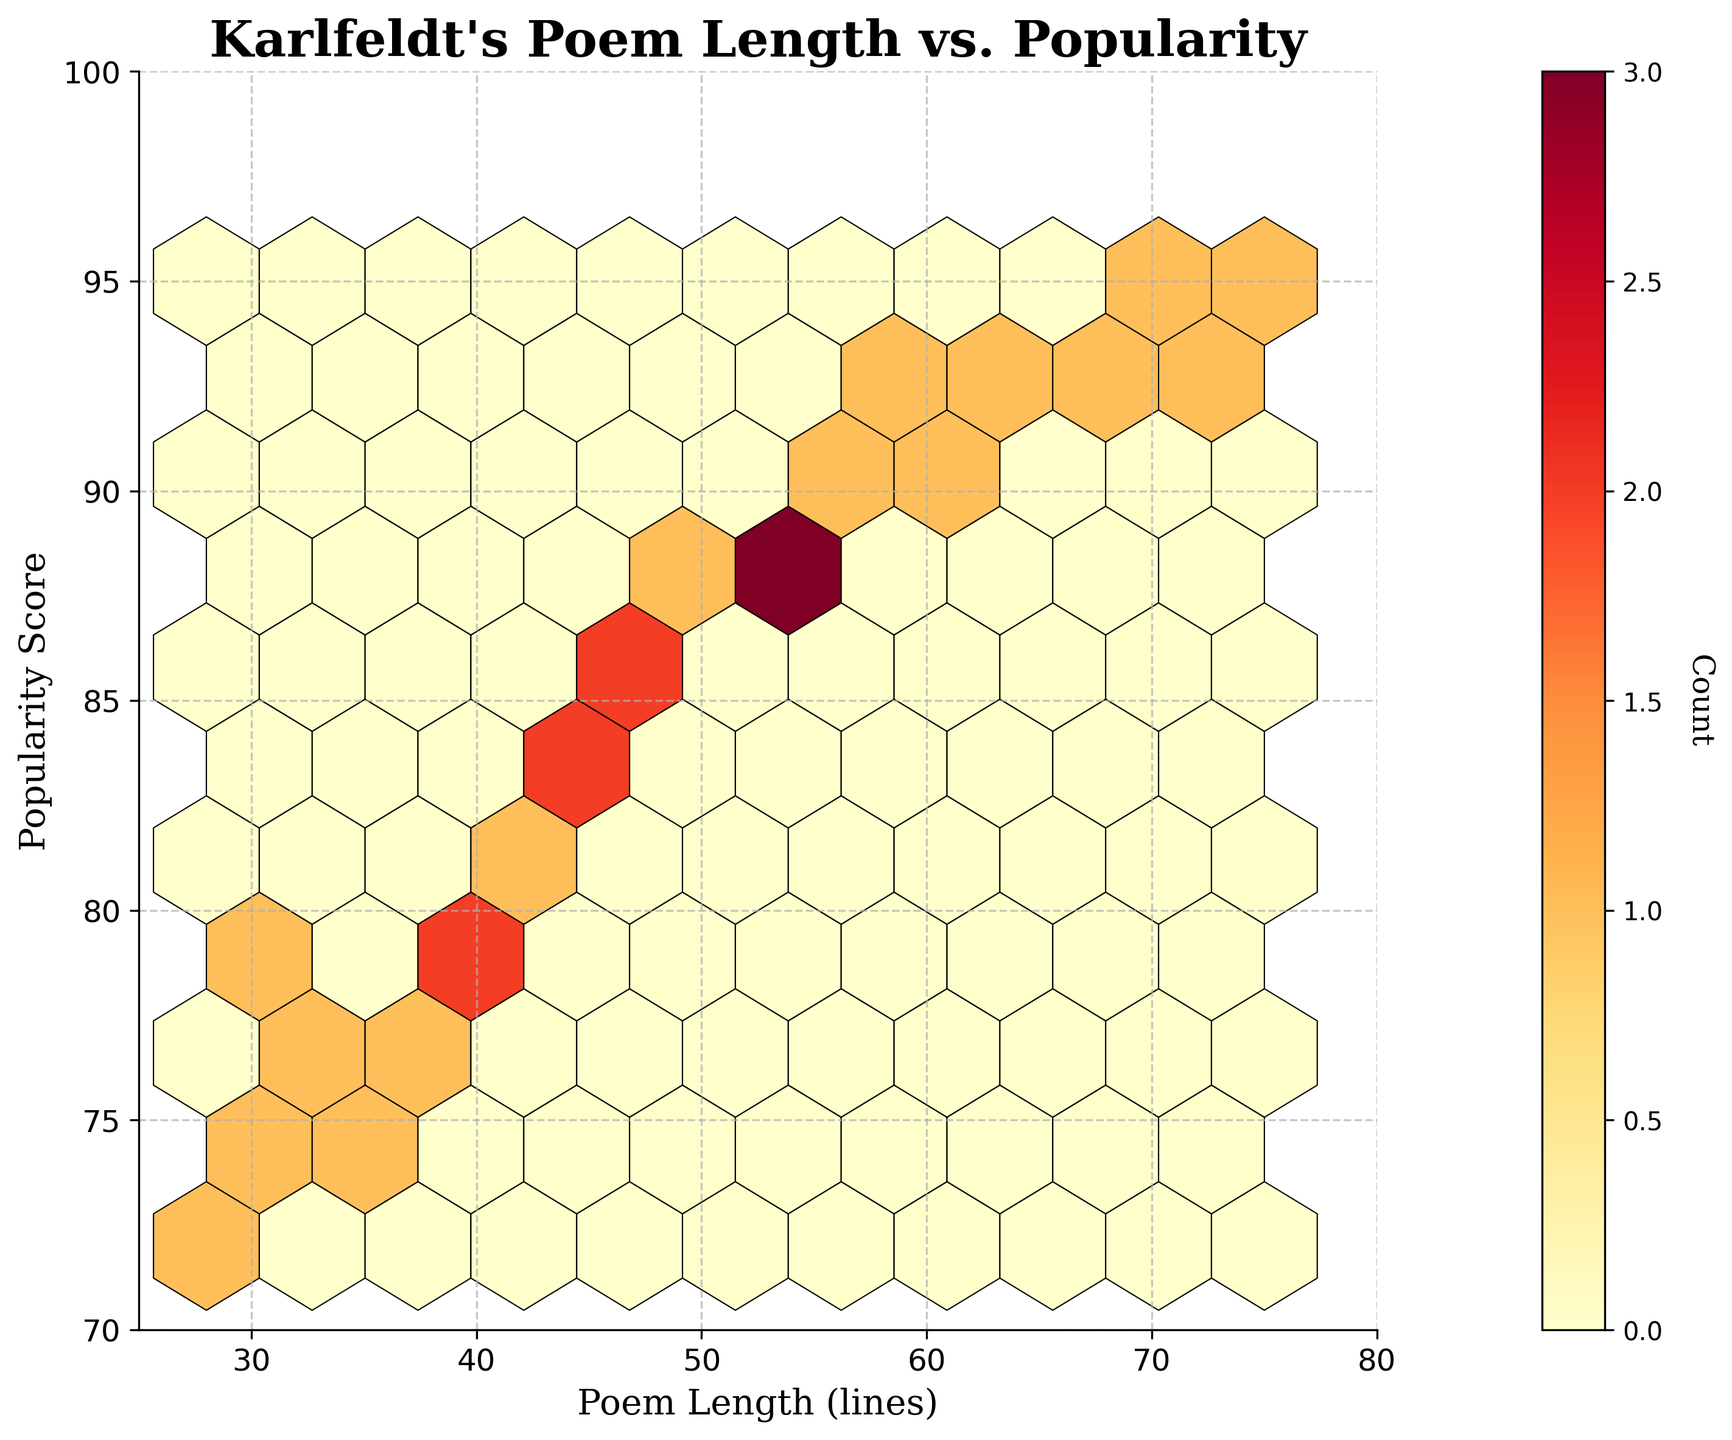What is the title of the figure? The title is usually found at the top of the figure. In this case, it clearly states the relationship being examined: "Karlfeldt's Poem Length vs. Popularity."
Answer: Karlfeldt's Poem Length vs. Popularity What is the range of poem lengths shown on the x-axis? The x-axis label is "Poem Length (lines)." The x-limits are set from 25 to 80, representing the range of poem lengths.
Answer: 25 to 80 What is the range of popularity scores shown on the y-axis? The y-axis label is "Popularity Score," and the y-limits are set from 70 to 100, indicating the range of popularity scores.
Answer: 70 to 100 What does the color intensity in the hexagons represent? The color bar on the right indicates that the color intensity represents the count of data points within each hexagon. The brighter the color, the higher the count.
Answer: Count of data points Which plot element indicates the frequency of poem lengths and popularity scores in particular ranges? The hexagonal cells and their color intensity indicate the frequency of data points in specific ranges of poem lengths and popularity scores. Bright colors represent higher frequencies.
Answer: Hexagonal cells How many hexagonal bins are present in the plot? The plot uses a gridsize of 10, dividing the space into 10 columns and rows of hexagonal bins, summing up to roughly 100 bins.
Answer: 100 (approximately) Which range of poem lengths is the most frequent according to the plot? Look for the hexagonal bins with the brightest color, indicating the highest frequency. The most frequent poem lengths seem to fall between 30 and 50 lines.
Answer: 30 to 50 lines What is the most frequent popularity score range in the plot? The brightest hexagonal bins show the range of highest frequency for popularity scores, which falls between 80 and 90.
Answer: 80 to 90 Are longer poems generally associated with higher popularity scores? By observing the distribution pattern, we see many darker hexagons toward the upper-right, suggesting a possible positive correlation between longer poems and higher popularity.
Answer: Yes Which ranges of poem lengths and popularity scores are least frequent? The darkest hexagonal bins, representing the lowest frequency, are in the ranges 25-30 lines and 70-75 popularity scores.
Answer: 25-30 lines and 70-75 popularity scores 